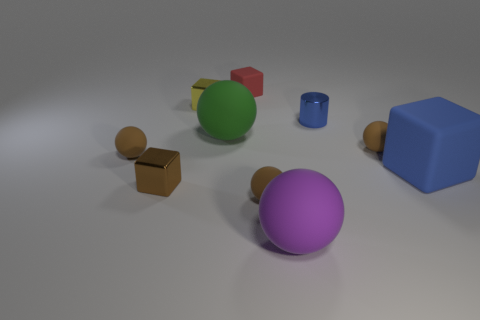Subtract all brown spheres. How many were subtracted if there are1brown spheres left? 2 Subtract all yellow cylinders. How many brown balls are left? 3 Subtract all green balls. How many balls are left? 4 Subtract all big purple rubber balls. How many balls are left? 4 Subtract all gray spheres. Subtract all gray cylinders. How many spheres are left? 5 Subtract all cubes. How many objects are left? 6 Subtract all purple matte things. Subtract all cyan matte blocks. How many objects are left? 9 Add 7 small yellow objects. How many small yellow objects are left? 8 Add 5 small red cylinders. How many small red cylinders exist? 5 Subtract 0 green blocks. How many objects are left? 10 